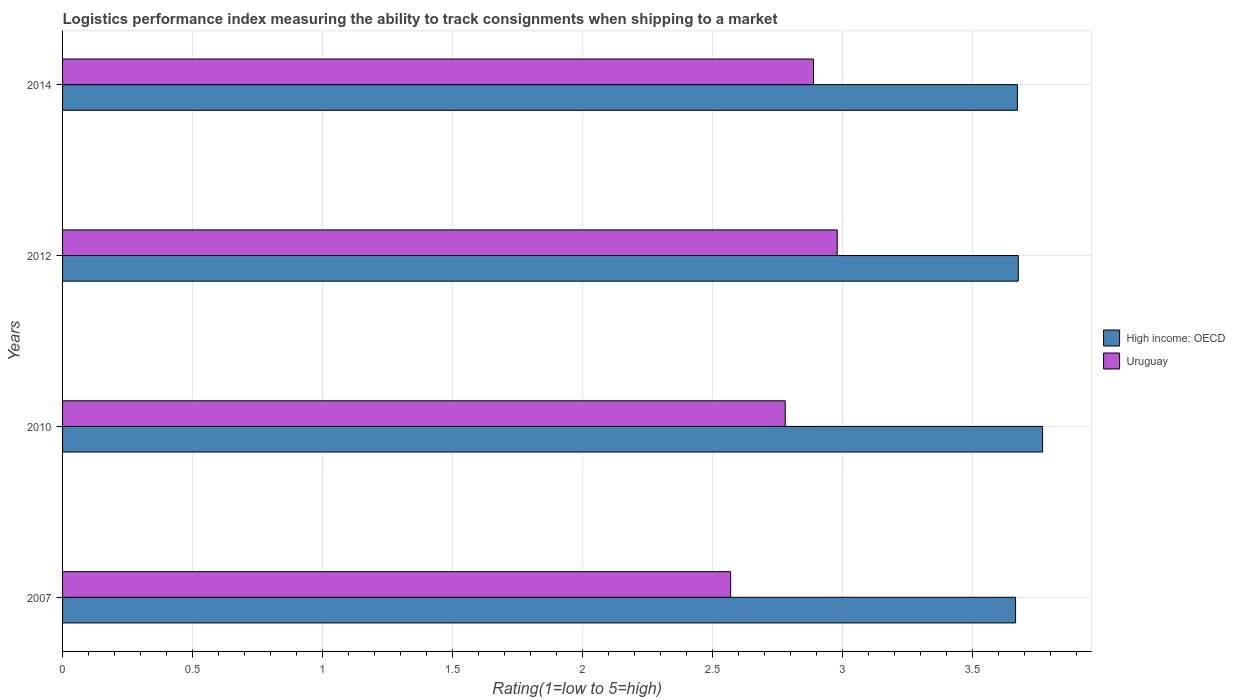How many different coloured bars are there?
Your answer should be compact. 2. How many bars are there on the 1st tick from the top?
Offer a very short reply. 2. How many bars are there on the 3rd tick from the bottom?
Your answer should be very brief. 2. What is the label of the 1st group of bars from the top?
Keep it short and to the point. 2014. In how many cases, is the number of bars for a given year not equal to the number of legend labels?
Provide a short and direct response. 0. What is the Logistic performance index in Uruguay in 2012?
Offer a terse response. 2.98. Across all years, what is the maximum Logistic performance index in High income: OECD?
Offer a terse response. 3.77. Across all years, what is the minimum Logistic performance index in High income: OECD?
Give a very brief answer. 3.67. In which year was the Logistic performance index in High income: OECD maximum?
Give a very brief answer. 2010. In which year was the Logistic performance index in Uruguay minimum?
Your answer should be compact. 2007. What is the total Logistic performance index in Uruguay in the graph?
Your answer should be compact. 11.22. What is the difference between the Logistic performance index in High income: OECD in 2010 and that in 2014?
Ensure brevity in your answer.  0.1. What is the difference between the Logistic performance index in High income: OECD in 2010 and the Logistic performance index in Uruguay in 2012?
Make the answer very short. 0.79. What is the average Logistic performance index in Uruguay per year?
Your response must be concise. 2.8. In the year 2010, what is the difference between the Logistic performance index in Uruguay and Logistic performance index in High income: OECD?
Ensure brevity in your answer.  -0.99. What is the ratio of the Logistic performance index in Uruguay in 2010 to that in 2014?
Give a very brief answer. 0.96. What is the difference between the highest and the second highest Logistic performance index in High income: OECD?
Offer a terse response. 0.09. What is the difference between the highest and the lowest Logistic performance index in High income: OECD?
Your answer should be very brief. 0.1. What does the 1st bar from the top in 2012 represents?
Offer a very short reply. Uruguay. What does the 1st bar from the bottom in 2014 represents?
Make the answer very short. High income: OECD. Are all the bars in the graph horizontal?
Your answer should be compact. Yes. What is the difference between two consecutive major ticks on the X-axis?
Provide a short and direct response. 0.5. Does the graph contain grids?
Your answer should be very brief. Yes. Where does the legend appear in the graph?
Provide a succinct answer. Center right. How are the legend labels stacked?
Offer a very short reply. Vertical. What is the title of the graph?
Provide a succinct answer. Logistics performance index measuring the ability to track consignments when shipping to a market. Does "Equatorial Guinea" appear as one of the legend labels in the graph?
Your answer should be compact. No. What is the label or title of the X-axis?
Offer a terse response. Rating(1=low to 5=high). What is the Rating(1=low to 5=high) of High income: OECD in 2007?
Provide a succinct answer. 3.67. What is the Rating(1=low to 5=high) in Uruguay in 2007?
Provide a short and direct response. 2.57. What is the Rating(1=low to 5=high) of High income: OECD in 2010?
Offer a very short reply. 3.77. What is the Rating(1=low to 5=high) of Uruguay in 2010?
Offer a terse response. 2.78. What is the Rating(1=low to 5=high) in High income: OECD in 2012?
Ensure brevity in your answer.  3.68. What is the Rating(1=low to 5=high) of Uruguay in 2012?
Offer a very short reply. 2.98. What is the Rating(1=low to 5=high) of High income: OECD in 2014?
Offer a very short reply. 3.67. What is the Rating(1=low to 5=high) of Uruguay in 2014?
Provide a succinct answer. 2.89. Across all years, what is the maximum Rating(1=low to 5=high) of High income: OECD?
Keep it short and to the point. 3.77. Across all years, what is the maximum Rating(1=low to 5=high) of Uruguay?
Keep it short and to the point. 2.98. Across all years, what is the minimum Rating(1=low to 5=high) in High income: OECD?
Provide a succinct answer. 3.67. Across all years, what is the minimum Rating(1=low to 5=high) in Uruguay?
Offer a terse response. 2.57. What is the total Rating(1=low to 5=high) of High income: OECD in the graph?
Provide a short and direct response. 14.79. What is the total Rating(1=low to 5=high) in Uruguay in the graph?
Your answer should be compact. 11.22. What is the difference between the Rating(1=low to 5=high) of High income: OECD in 2007 and that in 2010?
Your response must be concise. -0.1. What is the difference between the Rating(1=low to 5=high) of Uruguay in 2007 and that in 2010?
Make the answer very short. -0.21. What is the difference between the Rating(1=low to 5=high) of High income: OECD in 2007 and that in 2012?
Offer a very short reply. -0.01. What is the difference between the Rating(1=low to 5=high) in Uruguay in 2007 and that in 2012?
Provide a short and direct response. -0.41. What is the difference between the Rating(1=low to 5=high) in High income: OECD in 2007 and that in 2014?
Your answer should be compact. -0.01. What is the difference between the Rating(1=low to 5=high) in Uruguay in 2007 and that in 2014?
Your response must be concise. -0.32. What is the difference between the Rating(1=low to 5=high) of High income: OECD in 2010 and that in 2012?
Provide a short and direct response. 0.09. What is the difference between the Rating(1=low to 5=high) in Uruguay in 2010 and that in 2012?
Keep it short and to the point. -0.2. What is the difference between the Rating(1=low to 5=high) of High income: OECD in 2010 and that in 2014?
Give a very brief answer. 0.1. What is the difference between the Rating(1=low to 5=high) of Uruguay in 2010 and that in 2014?
Make the answer very short. -0.11. What is the difference between the Rating(1=low to 5=high) of High income: OECD in 2012 and that in 2014?
Keep it short and to the point. 0. What is the difference between the Rating(1=low to 5=high) in Uruguay in 2012 and that in 2014?
Make the answer very short. 0.09. What is the difference between the Rating(1=low to 5=high) of High income: OECD in 2007 and the Rating(1=low to 5=high) of Uruguay in 2010?
Keep it short and to the point. 0.89. What is the difference between the Rating(1=low to 5=high) in High income: OECD in 2007 and the Rating(1=low to 5=high) in Uruguay in 2012?
Ensure brevity in your answer.  0.69. What is the difference between the Rating(1=low to 5=high) in High income: OECD in 2007 and the Rating(1=low to 5=high) in Uruguay in 2014?
Your response must be concise. 0.78. What is the difference between the Rating(1=low to 5=high) of High income: OECD in 2010 and the Rating(1=low to 5=high) of Uruguay in 2012?
Provide a succinct answer. 0.79. What is the difference between the Rating(1=low to 5=high) of High income: OECD in 2010 and the Rating(1=low to 5=high) of Uruguay in 2014?
Your answer should be very brief. 0.88. What is the difference between the Rating(1=low to 5=high) of High income: OECD in 2012 and the Rating(1=low to 5=high) of Uruguay in 2014?
Keep it short and to the point. 0.79. What is the average Rating(1=low to 5=high) in High income: OECD per year?
Provide a short and direct response. 3.7. What is the average Rating(1=low to 5=high) of Uruguay per year?
Your answer should be very brief. 2.8. In the year 2007, what is the difference between the Rating(1=low to 5=high) in High income: OECD and Rating(1=low to 5=high) in Uruguay?
Your answer should be compact. 1.1. In the year 2010, what is the difference between the Rating(1=low to 5=high) of High income: OECD and Rating(1=low to 5=high) of Uruguay?
Your response must be concise. 0.99. In the year 2012, what is the difference between the Rating(1=low to 5=high) in High income: OECD and Rating(1=low to 5=high) in Uruguay?
Give a very brief answer. 0.7. In the year 2014, what is the difference between the Rating(1=low to 5=high) of High income: OECD and Rating(1=low to 5=high) of Uruguay?
Ensure brevity in your answer.  0.78. What is the ratio of the Rating(1=low to 5=high) in High income: OECD in 2007 to that in 2010?
Provide a succinct answer. 0.97. What is the ratio of the Rating(1=low to 5=high) in Uruguay in 2007 to that in 2010?
Ensure brevity in your answer.  0.92. What is the ratio of the Rating(1=low to 5=high) in Uruguay in 2007 to that in 2012?
Make the answer very short. 0.86. What is the ratio of the Rating(1=low to 5=high) of Uruguay in 2007 to that in 2014?
Keep it short and to the point. 0.89. What is the ratio of the Rating(1=low to 5=high) of High income: OECD in 2010 to that in 2012?
Your response must be concise. 1.03. What is the ratio of the Rating(1=low to 5=high) in Uruguay in 2010 to that in 2012?
Make the answer very short. 0.93. What is the ratio of the Rating(1=low to 5=high) of High income: OECD in 2010 to that in 2014?
Your answer should be very brief. 1.03. What is the ratio of the Rating(1=low to 5=high) in Uruguay in 2010 to that in 2014?
Make the answer very short. 0.96. What is the ratio of the Rating(1=low to 5=high) of Uruguay in 2012 to that in 2014?
Your answer should be compact. 1.03. What is the difference between the highest and the second highest Rating(1=low to 5=high) of High income: OECD?
Offer a very short reply. 0.09. What is the difference between the highest and the second highest Rating(1=low to 5=high) of Uruguay?
Keep it short and to the point. 0.09. What is the difference between the highest and the lowest Rating(1=low to 5=high) in High income: OECD?
Give a very brief answer. 0.1. What is the difference between the highest and the lowest Rating(1=low to 5=high) in Uruguay?
Provide a short and direct response. 0.41. 